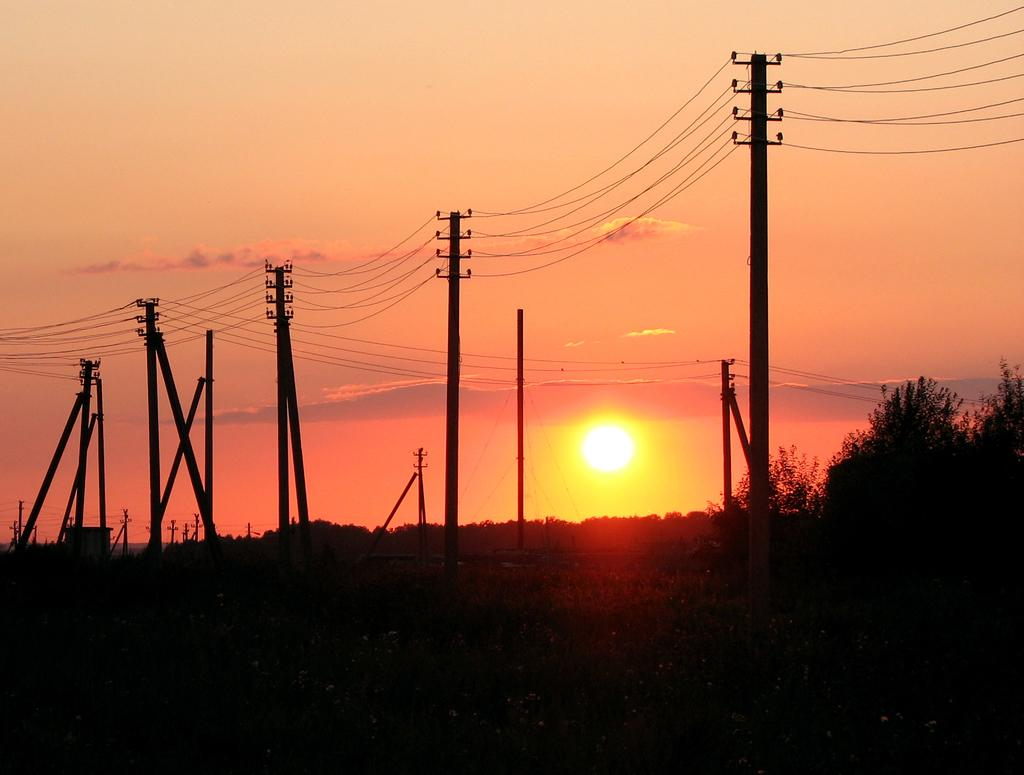What structures are standing on the ground in the image? There are electric poles standing on the ground in the image. What can be seen in the background of the image? There are trees visible in the background of the image. What celestial body is observable in the sky? The sun is observable in the sky. What type of motion can be seen in the image involving trains? There are no trains present in the image, so no motion involving trains can be observed. 